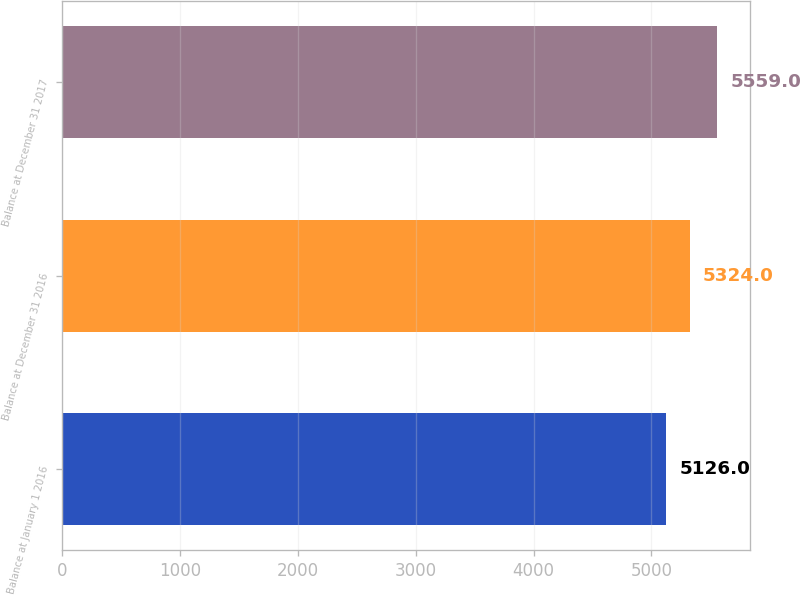Convert chart. <chart><loc_0><loc_0><loc_500><loc_500><bar_chart><fcel>Balance at January 1 2016<fcel>Balance at December 31 2016<fcel>Balance at December 31 2017<nl><fcel>5126<fcel>5324<fcel>5559<nl></chart> 